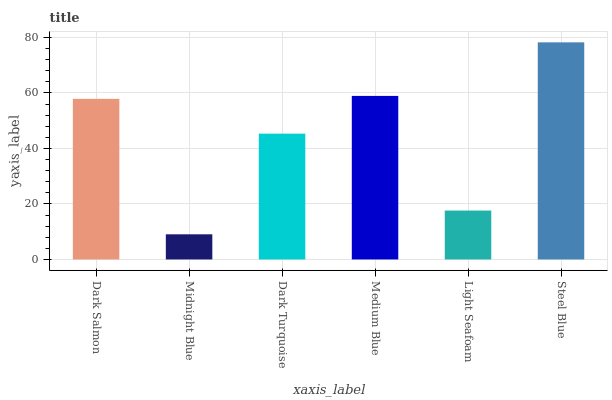Is Midnight Blue the minimum?
Answer yes or no. Yes. Is Steel Blue the maximum?
Answer yes or no. Yes. Is Dark Turquoise the minimum?
Answer yes or no. No. Is Dark Turquoise the maximum?
Answer yes or no. No. Is Dark Turquoise greater than Midnight Blue?
Answer yes or no. Yes. Is Midnight Blue less than Dark Turquoise?
Answer yes or no. Yes. Is Midnight Blue greater than Dark Turquoise?
Answer yes or no. No. Is Dark Turquoise less than Midnight Blue?
Answer yes or no. No. Is Dark Salmon the high median?
Answer yes or no. Yes. Is Dark Turquoise the low median?
Answer yes or no. Yes. Is Dark Turquoise the high median?
Answer yes or no. No. Is Medium Blue the low median?
Answer yes or no. No. 